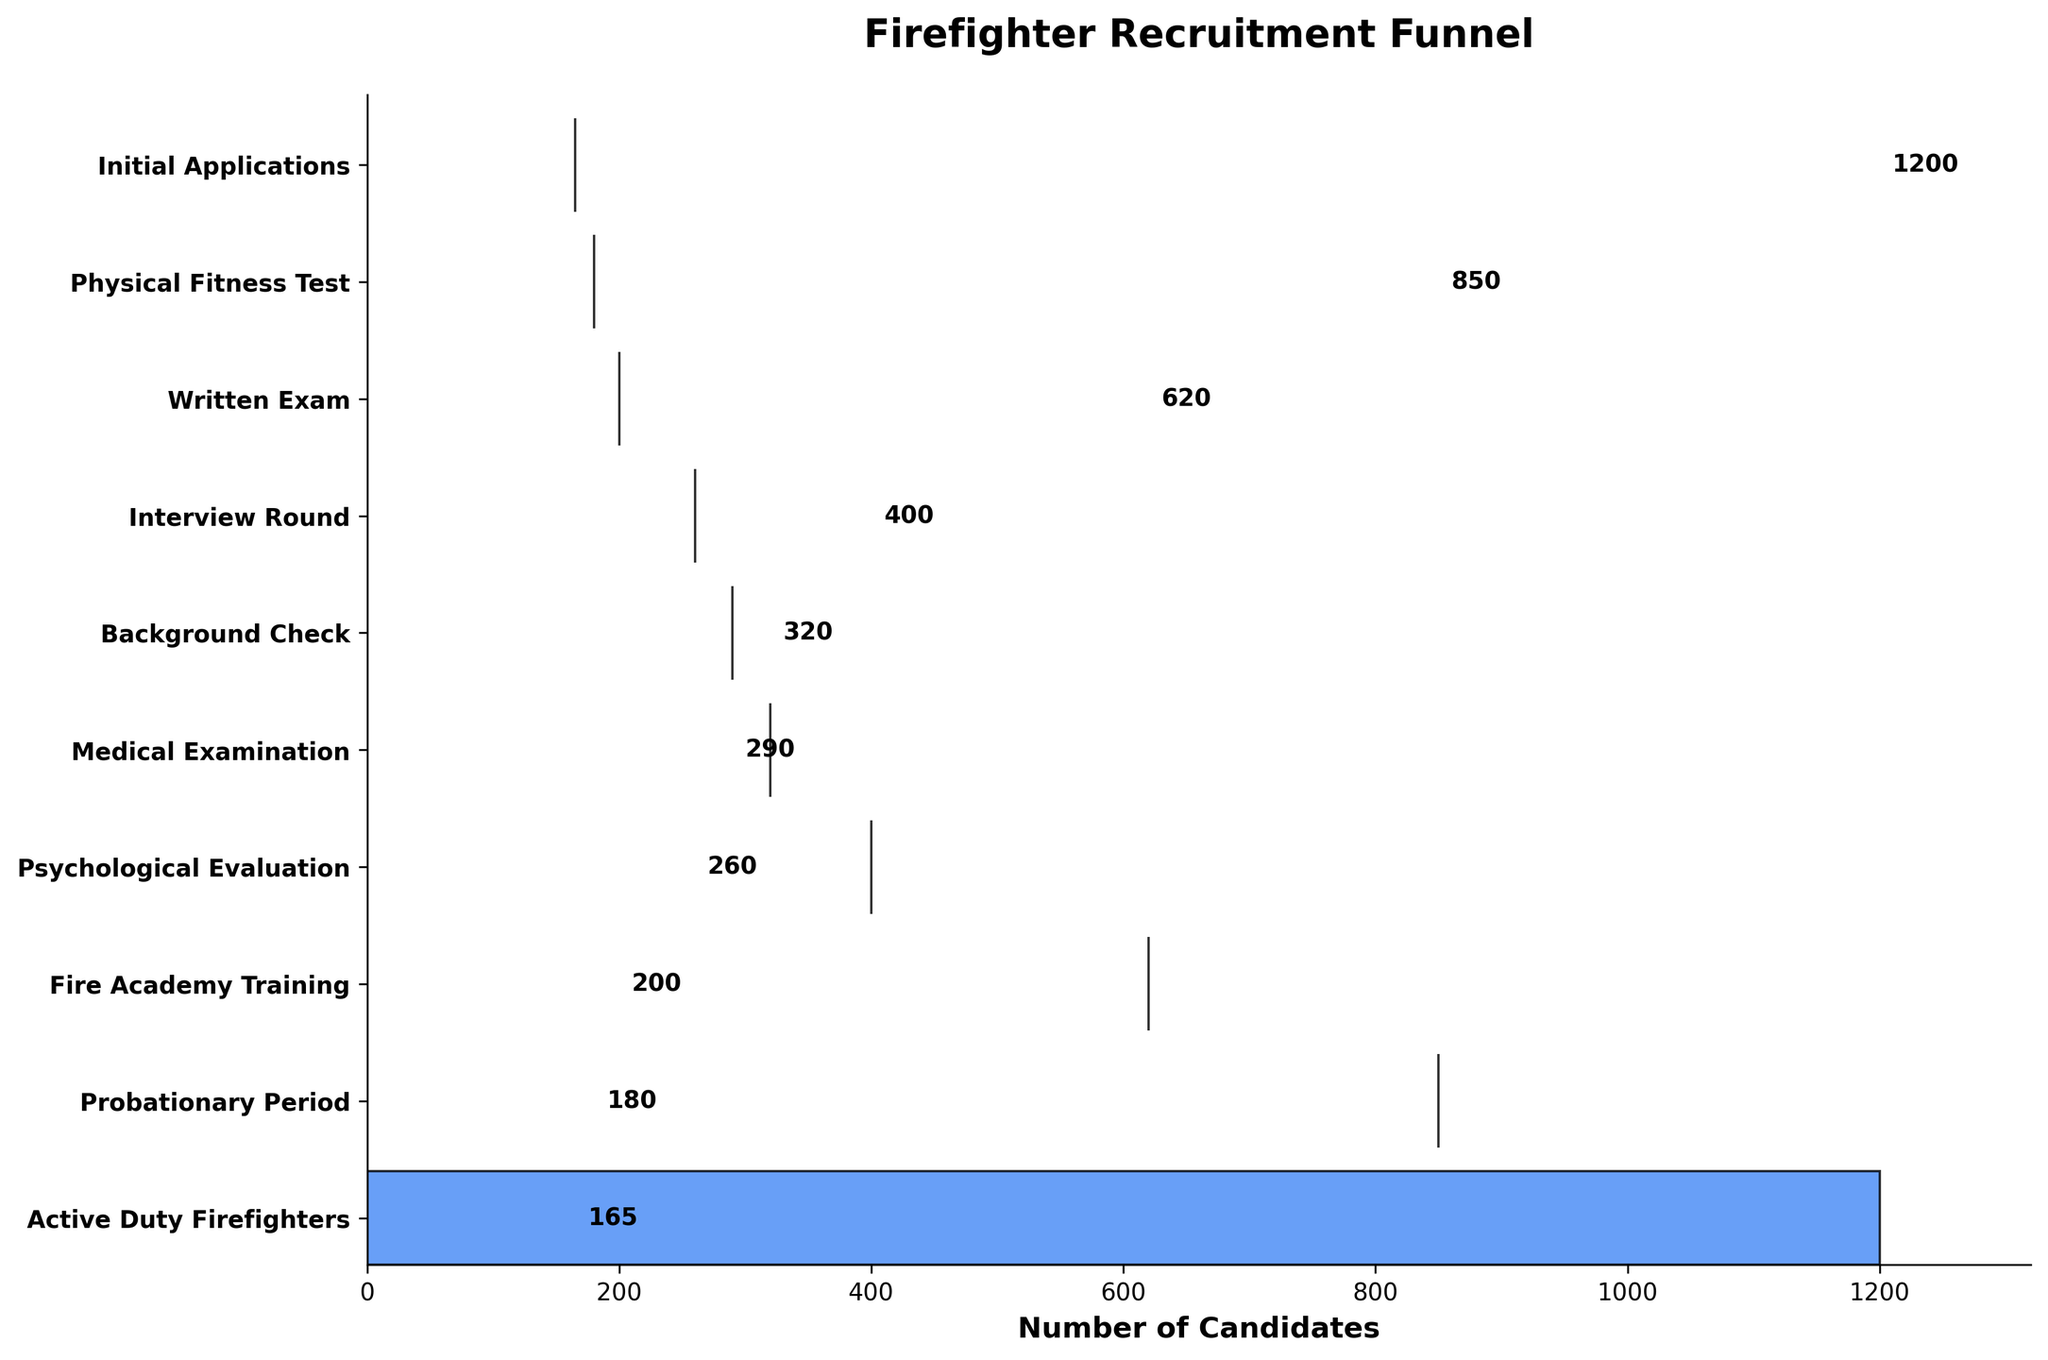How many candidates passed the Physical Fitness Test? The figure shows various stages in the firefighter recruitment process along with the number of candidates at each stage. From the "Physical Fitness Test" stage, it's indicated that 850 candidates passed.
Answer: 850 What is the drop-off in the number of candidates from the "Written Exam" to the "Interview Round"? From the figure, the "Written Exam" stage has 620 candidates, and the "Interview Round" has 400 candidates. The difference is 620 - 400 = 220.
Answer: 220 Which stage has the smallest reduction in the number of candidates? By comparing the reductions in the number of candidates at each stage in the figure, the smallest reduction is from "Background Check" to "Medical Examination" which is 320 - 290 = 30.
Answer: Background Check to Medical Examination How many stages are there in the firefighter recruitment funnel? The figure lists the stages from "Initial Applications" to "Active Duty Firefighters". Counting these stages gives us a total of 10 stages.
Answer: 10 Which stage sees the highest number of candidates and what is that number? The figure shows the number of candidates at each stage. The "Initial Applications" stage has the highest number of candidates, which is 1200.
Answer: Initial Applications, 1200 What is the total reduction in candidate numbers from "Initial Applications" to "Active Duty Firefighters"? Starting with 1200 candidates in "Initial Applications" and ending with 165 in "Active Duty Firefighters", the reduction is 1200 - 165 = 1035.
Answer: 1035 What percentage of candidates from the "Psychological Evaluation" stage reach the "Active Duty Firefighters" stage? The figure shows that 260 candidates moved to the "Psychological Evaluation" stage and 165 to "Active Duty Firefighters". The percentage is calculated as (165 / 260) * 100 ≈ 63.46%.
Answer: ≈ 63.46% From which stage to which stage is the number of candidates reduced by exactly 20? The figure indicates that "Fire Academy Training" has 200 candidates and "Probationary Period" has 180 candidates, making the reduction 200 - 180 = 20.
Answer: Fire Academy Training to Probationary Period 